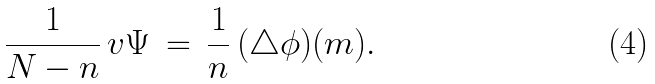<formula> <loc_0><loc_0><loc_500><loc_500>\frac { 1 } { N - n } \, v \Psi \, = \, \frac { 1 } { n } \, ( \triangle \phi ) ( m ) .</formula> 